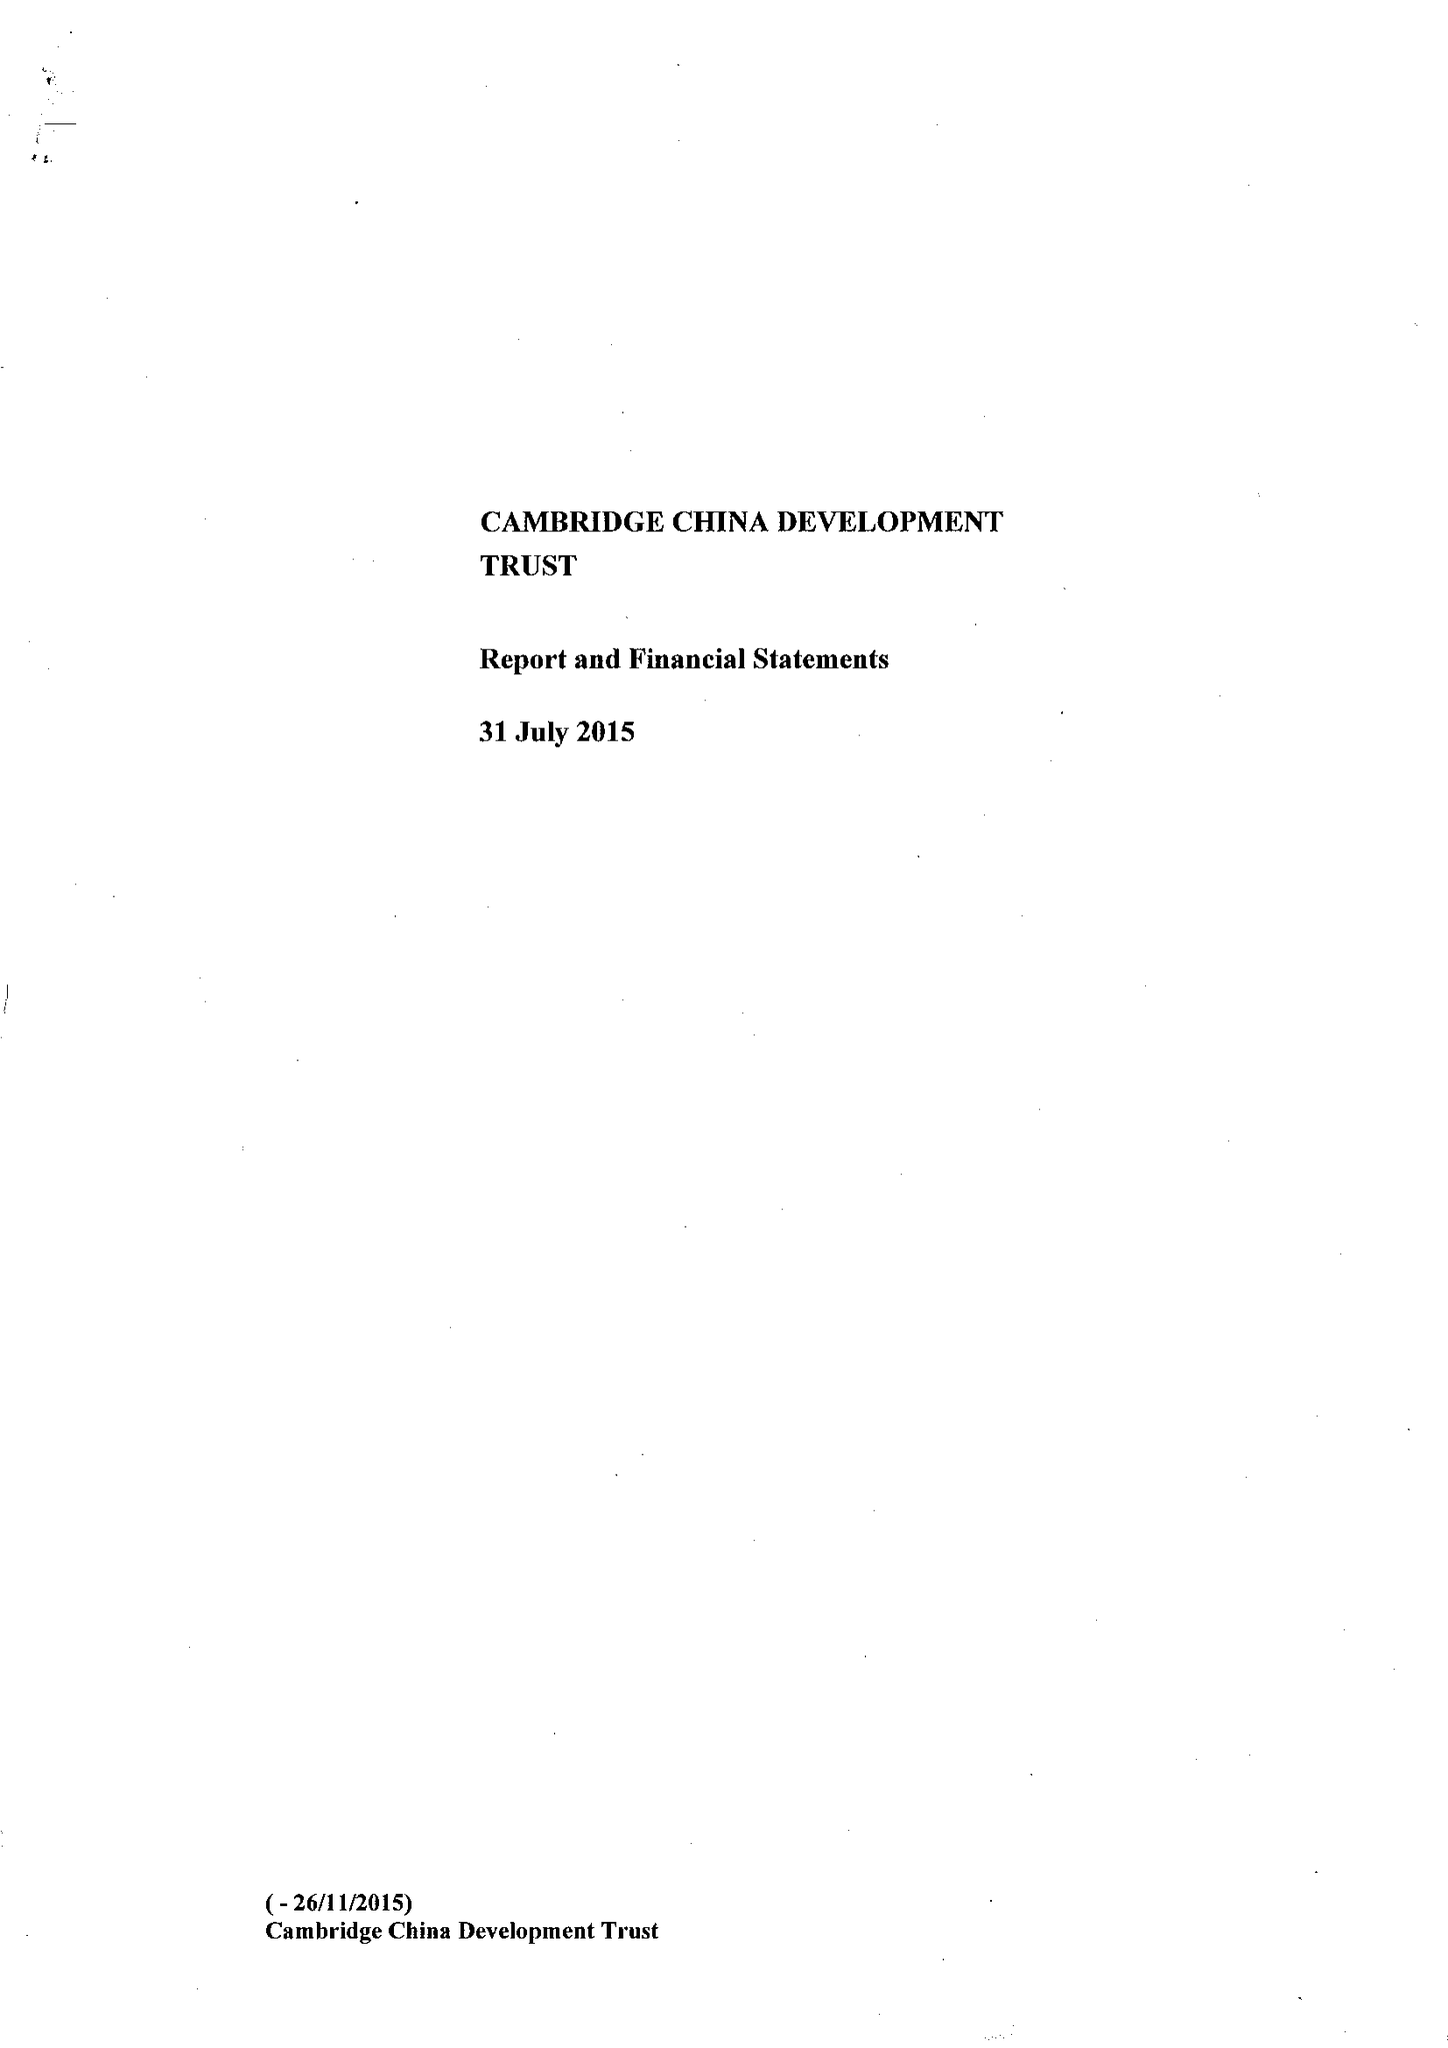What is the value for the charity_name?
Answer the question using a single word or phrase. The Cambridge China Development Trust 